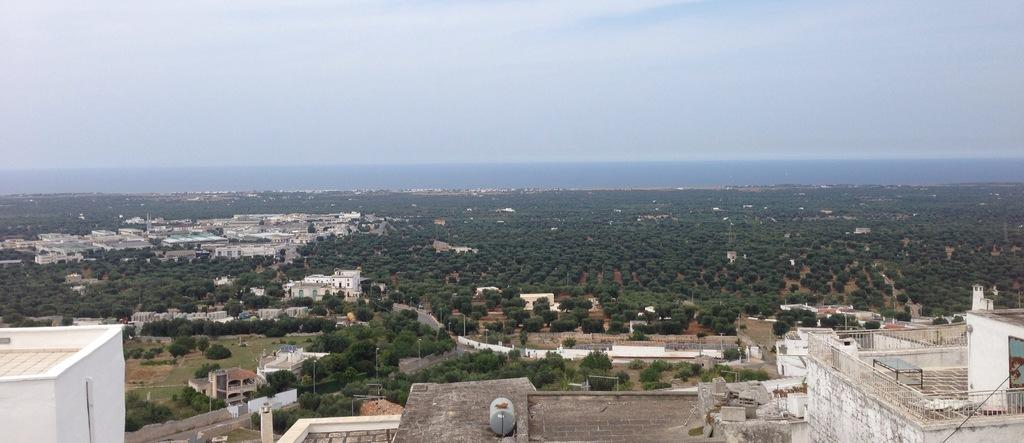What type of structures can be seen in the image? There are buildings in the image. What natural elements are present in the image? There are trees in the image. What architectural features can be observed in the image? There are windows and poles in the image. What objects are related to cooking or outdoor activities in the image? There are grills in the image. What else can be seen in the image besides the mentioned elements? There are there other objects? What can be seen in the background of the image? The sky is visible in the background of the image. How many berries are on the visitor's plate in the image? There is no visitor or plate with berries present in the image. What type of cellar can be seen in the image? There is no cellar present in the image. 